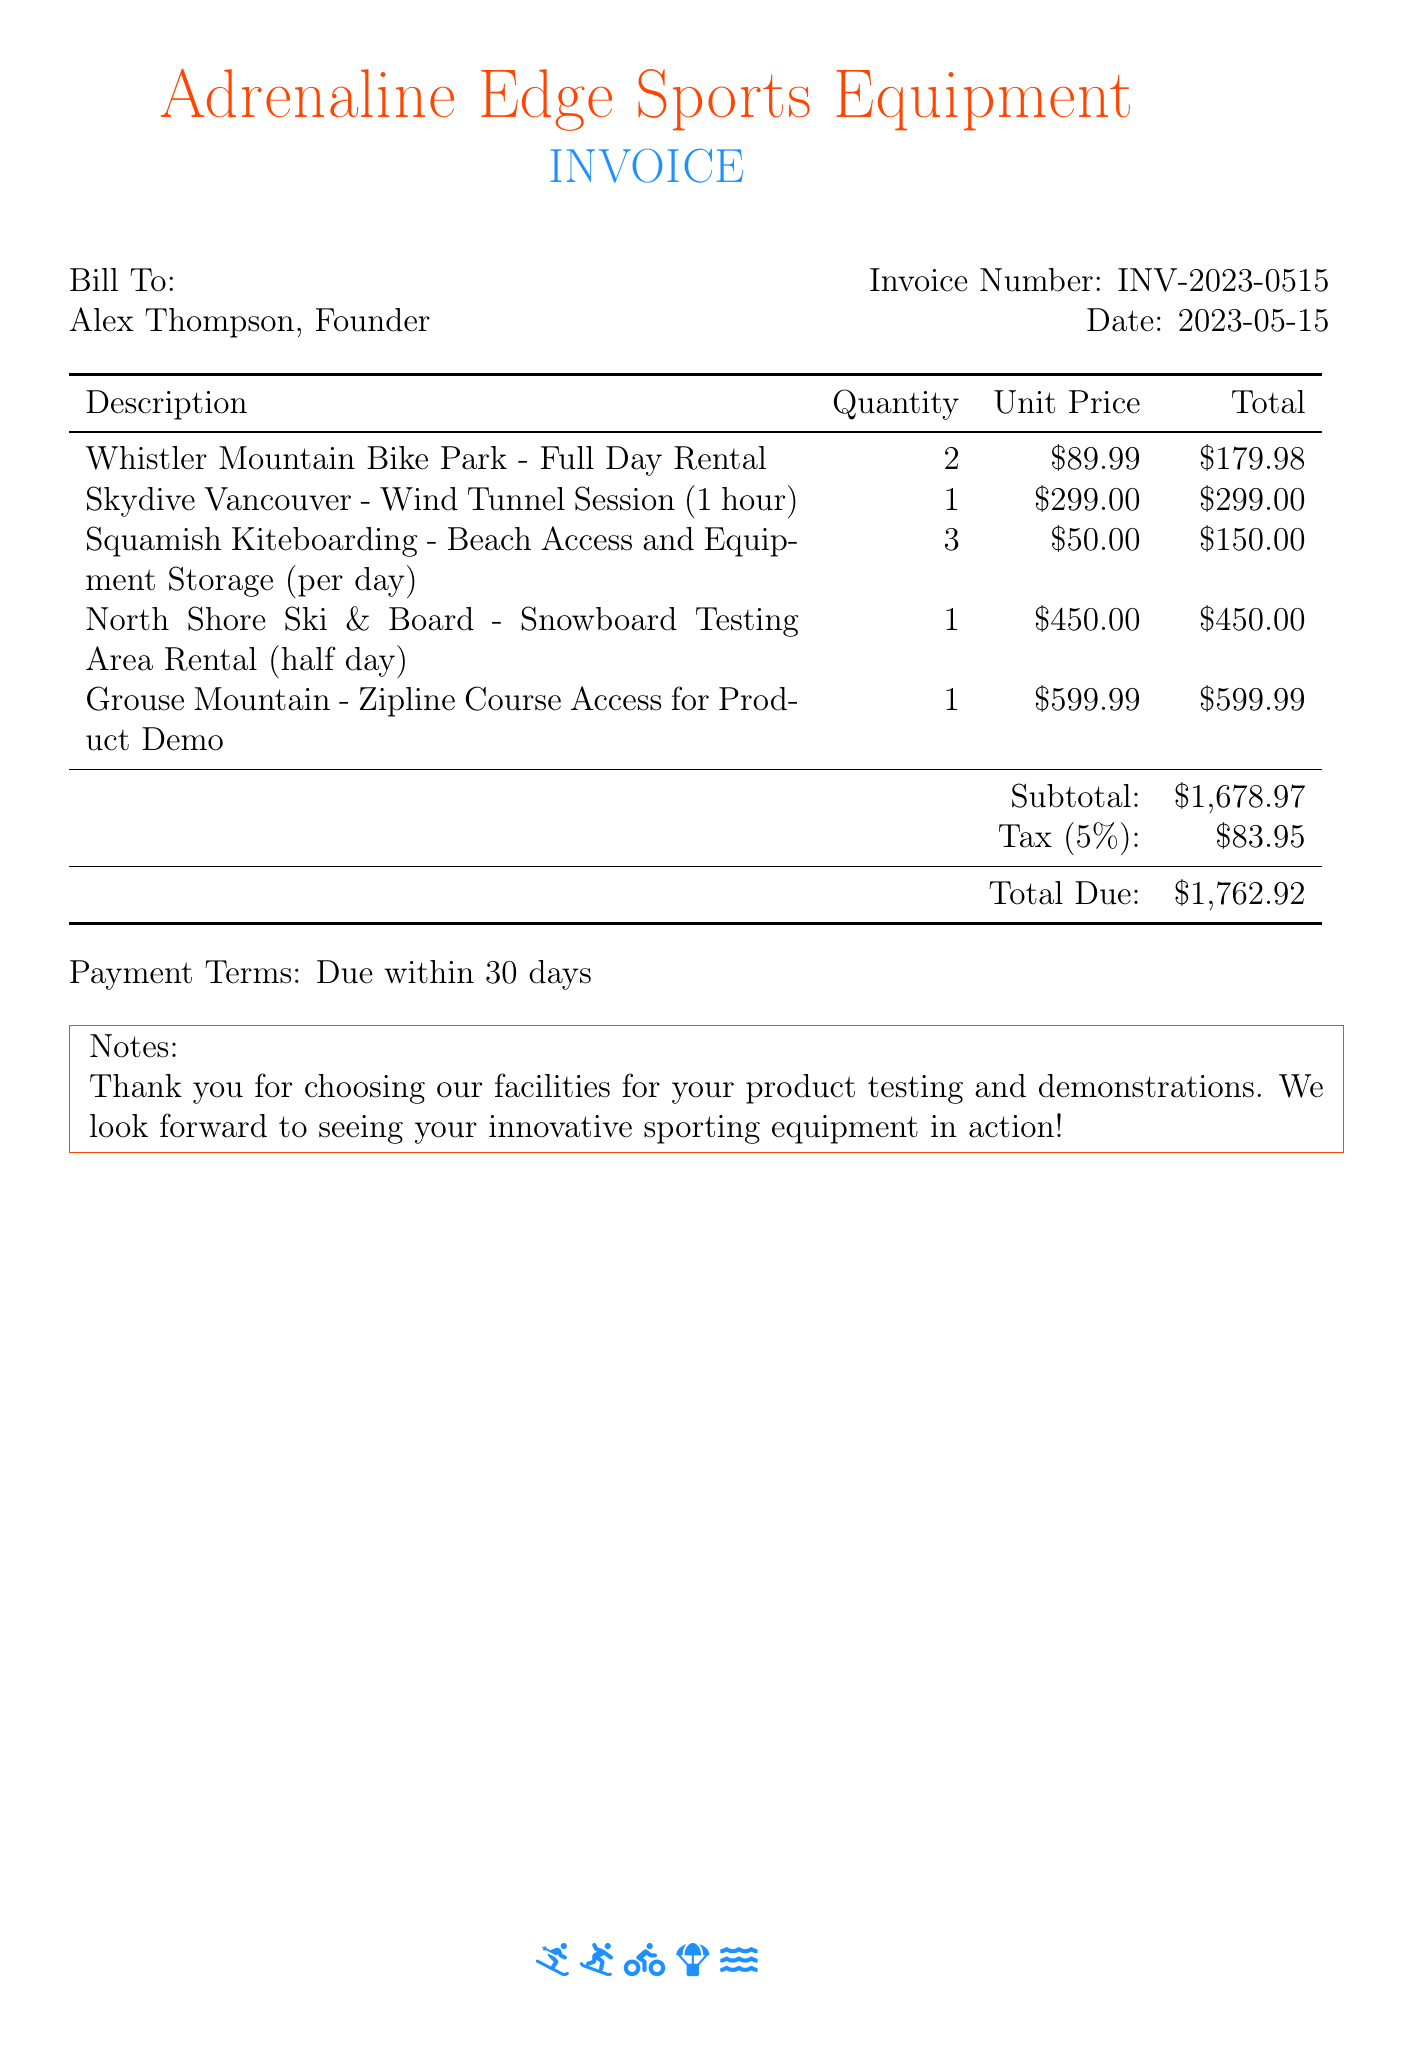What is the invoice number? The invoice number is stated in the document as INV-2023-0515.
Answer: INV-2023-0515 What is the total due amount? The total due amount is calculated at the end of the document and is listed as $1,762.92.
Answer: $1,762.92 How many facilities were rented for product testing? The document lists five different facility rentals for product testing, demonstrating multiple locations.
Answer: Five What is the unit price for the Wind Tunnel Session? The document provides the unit price for the Wind Tunnel Session as $299.00.
Answer: $299.00 What is the subtotal before tax? The subtotal before tax is clearly stated as $1,678.97 in the document.
Answer: $1,678.97 What type of document is this? This document is an invoice specifically related to extreme sports facilities rentals.
Answer: Invoice What is the tax percentage applied? The document mentions a tax rate of 5% applied to the subtotal.
Answer: 5% When is the payment due? The payment terms specify that payment is due within 30 days.
Answer: 30 days What is the name of the company issuing the invoice? The company issuing the invoice is named Adrenaline Edge Sports Equipment.
Answer: Adrenaline Edge Sports Equipment 